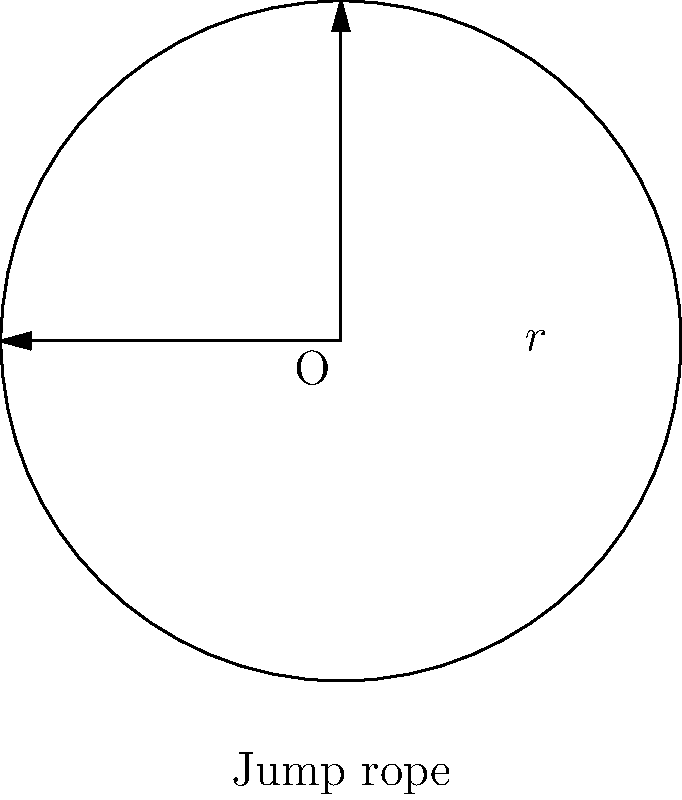As a busy mom, you're organizing a jump rope activity for your child's birthday party. You want to ensure the jump rope is the right length for the kids to use comfortably. If the radius of the circular path the jump rope makes is 3 feet, what is the minimum length of jump rope needed? (Assume the rope forms a perfect circle when swung, and round your answer to the nearest foot.) Let's approach this step-by-step:

1) The jump rope forms a circle when swung. We need to find the circumference of this circle.

2) The formula for the circumference of a circle is:
   $C = 2\pi r$
   where $C$ is the circumference and $r$ is the radius.

3) We're given that the radius is 3 feet.

4) Let's substitute this into our formula:
   $C = 2\pi (3)$

5) Simplify:
   $C = 6\pi$

6) Calculate:
   $C \approx 18.85$ feet

7) Rounding to the nearest foot:
   $C \approx 19$ feet

Therefore, the minimum length of jump rope needed is approximately 19 feet.
Answer: 19 feet 